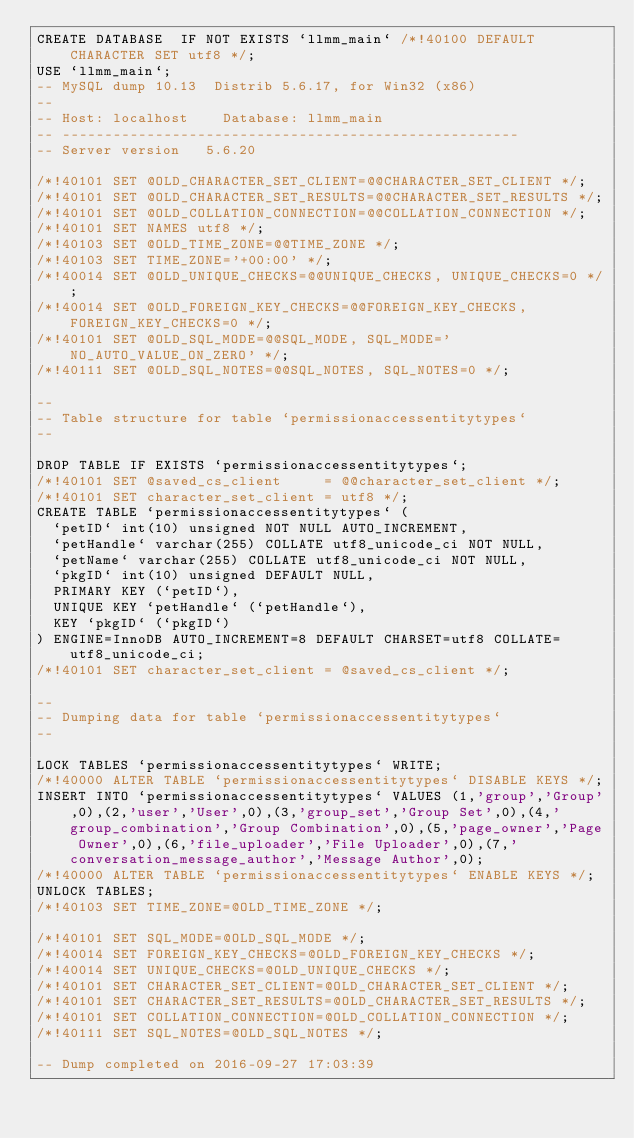<code> <loc_0><loc_0><loc_500><loc_500><_SQL_>CREATE DATABASE  IF NOT EXISTS `llmm_main` /*!40100 DEFAULT CHARACTER SET utf8 */;
USE `llmm_main`;
-- MySQL dump 10.13  Distrib 5.6.17, for Win32 (x86)
--
-- Host: localhost    Database: llmm_main
-- ------------------------------------------------------
-- Server version	5.6.20

/*!40101 SET @OLD_CHARACTER_SET_CLIENT=@@CHARACTER_SET_CLIENT */;
/*!40101 SET @OLD_CHARACTER_SET_RESULTS=@@CHARACTER_SET_RESULTS */;
/*!40101 SET @OLD_COLLATION_CONNECTION=@@COLLATION_CONNECTION */;
/*!40101 SET NAMES utf8 */;
/*!40103 SET @OLD_TIME_ZONE=@@TIME_ZONE */;
/*!40103 SET TIME_ZONE='+00:00' */;
/*!40014 SET @OLD_UNIQUE_CHECKS=@@UNIQUE_CHECKS, UNIQUE_CHECKS=0 */;
/*!40014 SET @OLD_FOREIGN_KEY_CHECKS=@@FOREIGN_KEY_CHECKS, FOREIGN_KEY_CHECKS=0 */;
/*!40101 SET @OLD_SQL_MODE=@@SQL_MODE, SQL_MODE='NO_AUTO_VALUE_ON_ZERO' */;
/*!40111 SET @OLD_SQL_NOTES=@@SQL_NOTES, SQL_NOTES=0 */;

--
-- Table structure for table `permissionaccessentitytypes`
--

DROP TABLE IF EXISTS `permissionaccessentitytypes`;
/*!40101 SET @saved_cs_client     = @@character_set_client */;
/*!40101 SET character_set_client = utf8 */;
CREATE TABLE `permissionaccessentitytypes` (
  `petID` int(10) unsigned NOT NULL AUTO_INCREMENT,
  `petHandle` varchar(255) COLLATE utf8_unicode_ci NOT NULL,
  `petName` varchar(255) COLLATE utf8_unicode_ci NOT NULL,
  `pkgID` int(10) unsigned DEFAULT NULL,
  PRIMARY KEY (`petID`),
  UNIQUE KEY `petHandle` (`petHandle`),
  KEY `pkgID` (`pkgID`)
) ENGINE=InnoDB AUTO_INCREMENT=8 DEFAULT CHARSET=utf8 COLLATE=utf8_unicode_ci;
/*!40101 SET character_set_client = @saved_cs_client */;

--
-- Dumping data for table `permissionaccessentitytypes`
--

LOCK TABLES `permissionaccessentitytypes` WRITE;
/*!40000 ALTER TABLE `permissionaccessentitytypes` DISABLE KEYS */;
INSERT INTO `permissionaccessentitytypes` VALUES (1,'group','Group',0),(2,'user','User',0),(3,'group_set','Group Set',0),(4,'group_combination','Group Combination',0),(5,'page_owner','Page Owner',0),(6,'file_uploader','File Uploader',0),(7,'conversation_message_author','Message Author',0);
/*!40000 ALTER TABLE `permissionaccessentitytypes` ENABLE KEYS */;
UNLOCK TABLES;
/*!40103 SET TIME_ZONE=@OLD_TIME_ZONE */;

/*!40101 SET SQL_MODE=@OLD_SQL_MODE */;
/*!40014 SET FOREIGN_KEY_CHECKS=@OLD_FOREIGN_KEY_CHECKS */;
/*!40014 SET UNIQUE_CHECKS=@OLD_UNIQUE_CHECKS */;
/*!40101 SET CHARACTER_SET_CLIENT=@OLD_CHARACTER_SET_CLIENT */;
/*!40101 SET CHARACTER_SET_RESULTS=@OLD_CHARACTER_SET_RESULTS */;
/*!40101 SET COLLATION_CONNECTION=@OLD_COLLATION_CONNECTION */;
/*!40111 SET SQL_NOTES=@OLD_SQL_NOTES */;

-- Dump completed on 2016-09-27 17:03:39
</code> 